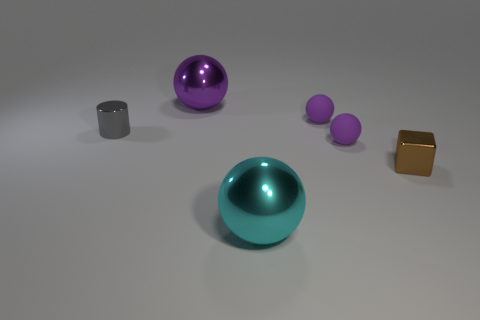What number of small objects are both left of the brown thing and right of the cyan ball?
Provide a short and direct response. 2. How many other things are there of the same material as the big cyan thing?
Make the answer very short. 3. Is the material of the big ball that is behind the small brown shiny object the same as the big cyan object?
Give a very brief answer. Yes. There is a gray thing that is behind the brown shiny thing that is on the right side of the big thing in front of the big purple object; what is its size?
Your answer should be compact. Small. What is the shape of the gray object that is the same size as the cube?
Your answer should be compact. Cylinder. There is a metallic sphere that is in front of the gray metallic thing; what size is it?
Provide a succinct answer. Large. Do the big ball that is behind the shiny block and the small ball that is behind the cylinder have the same color?
Provide a succinct answer. Yes. What is the small thing to the left of the metallic ball that is to the left of the large metallic sphere that is right of the big purple shiny thing made of?
Your response must be concise. Metal. Are there any purple matte things of the same size as the brown shiny block?
Make the answer very short. Yes. There is a brown thing that is in front of the metal cylinder; what shape is it?
Offer a terse response. Cube. 